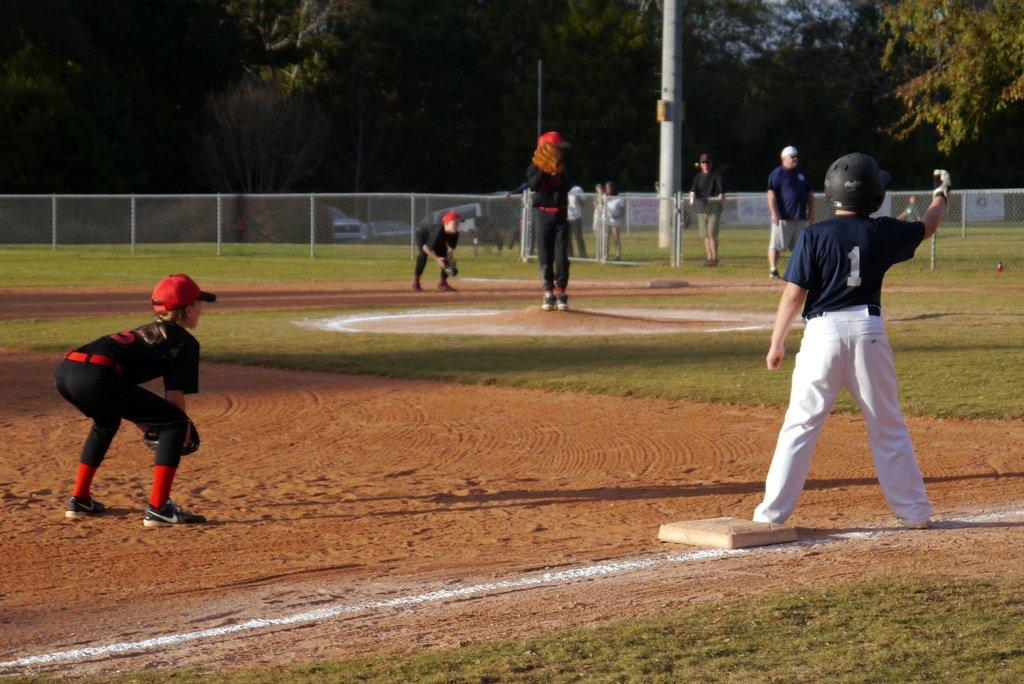How many people are in the image? There are people in the image, but the exact number is not specified. What are some of the people doing in the image? Some people are playing a game on the ground. Can you describe the object in the image? The description of the object is not provided in the facts. What can be seen in the background of the image? In the background of the image, there is mesh, a pole, trees, vehicles, rods, and banners. What type of copper material is used to make the calendar in the image? There is no copper material or calendar present in the image. How does the steam affect the game being played in the image? There is no steam present in the image, so it cannot affect the game being played. 